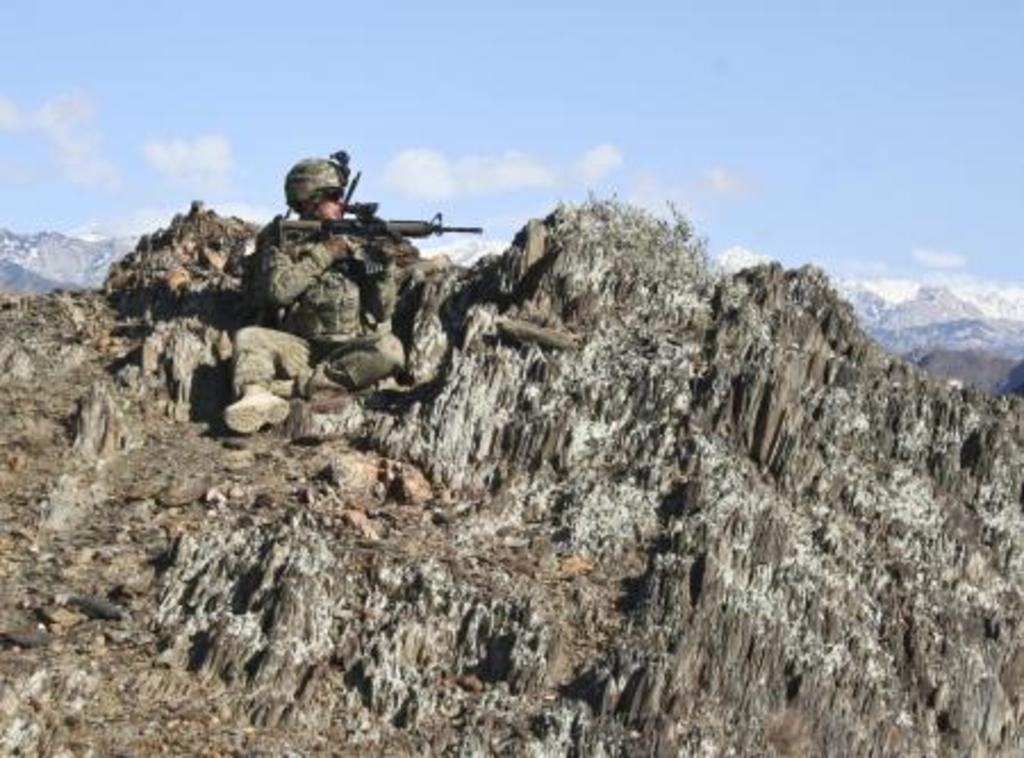What is the person in the image doing? The person is sitting on a mountain and holding a gun. How many mountains can be seen in the image? There are multiple mountains visible in the image. What is present in the sky in the image? There are clouds in the sky. What time of day is it in the image, and is there any thunder present? The time of day is not mentioned in the image, and there is no thunder present. 